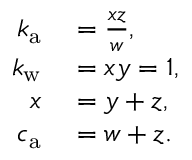Convert formula to latex. <formula><loc_0><loc_0><loc_500><loc_500>\begin{array} { r l } { k _ { a } } & = \frac { x z } { w } , } \\ { k _ { w } } & = x y = 1 , } \\ { x } & = y + z , } \\ { c _ { a } } & = w + z . } \end{array}</formula> 